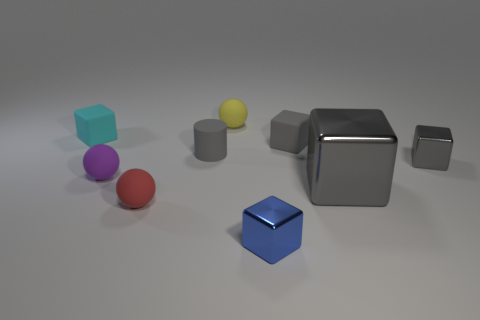Subtract all purple balls. How many gray cubes are left? 3 Subtract all tiny blue metal cubes. How many cubes are left? 4 Add 1 tiny purple metal blocks. How many objects exist? 10 Subtract all blue blocks. How many blocks are left? 4 Subtract 2 cubes. How many cubes are left? 3 Subtract all red cubes. Subtract all purple cylinders. How many cubes are left? 5 Subtract all cubes. How many objects are left? 4 Add 3 tiny rubber objects. How many tiny rubber objects exist? 9 Subtract 0 brown cylinders. How many objects are left? 9 Subtract all large purple rubber cylinders. Subtract all small matte blocks. How many objects are left? 7 